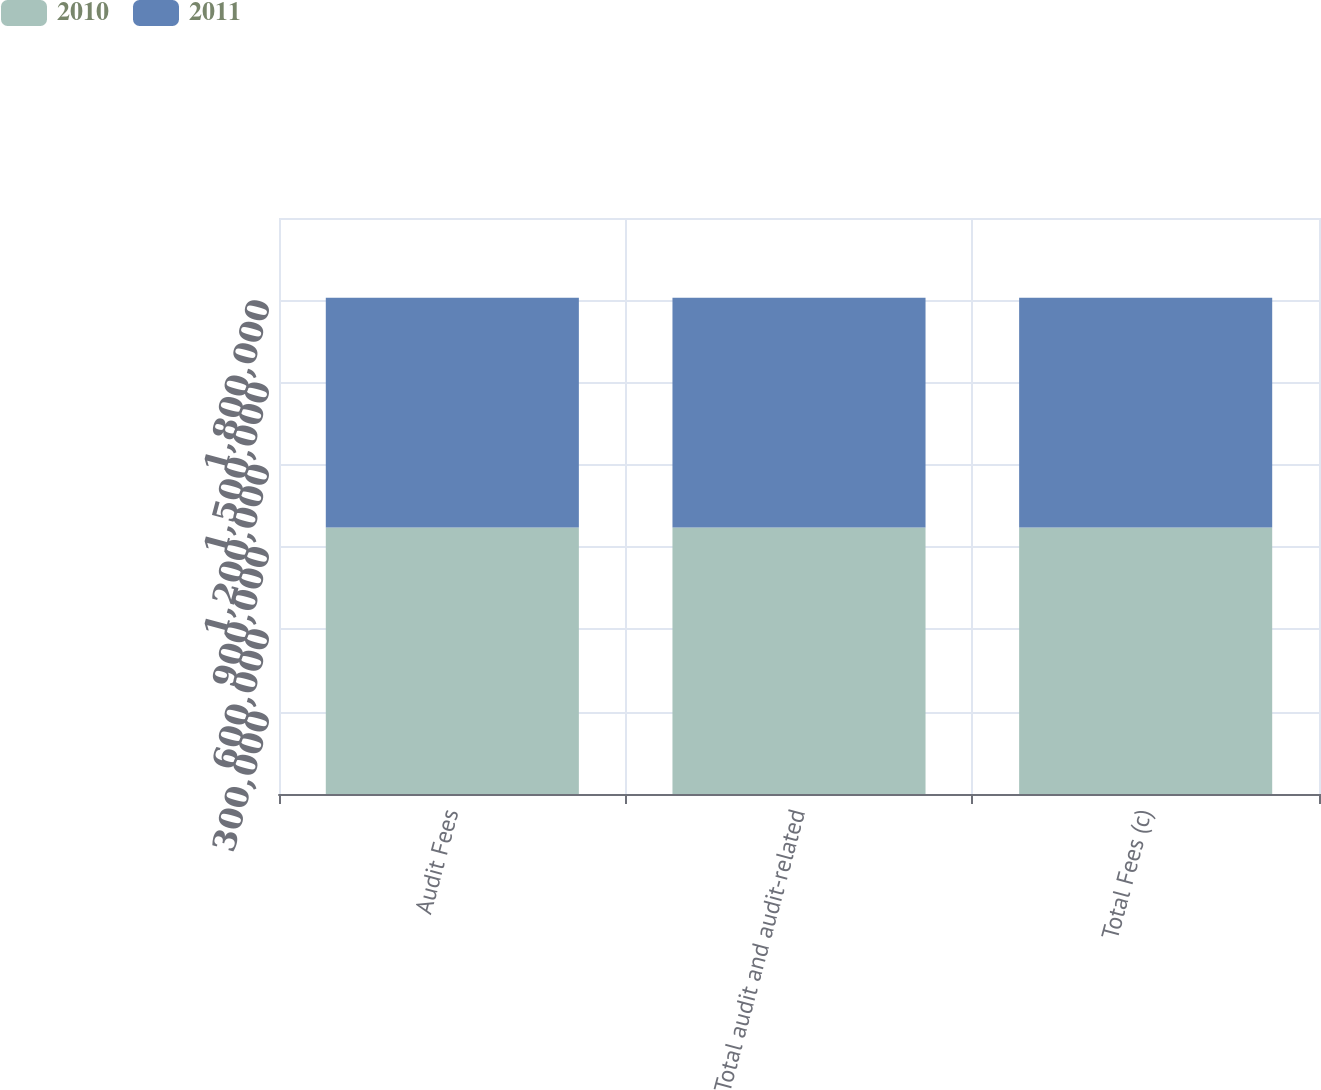Convert chart to OTSL. <chart><loc_0><loc_0><loc_500><loc_500><stacked_bar_chart><ecel><fcel>Audit Fees<fcel>Total audit and audit-related<fcel>Total Fees (c)<nl><fcel>2010<fcel>971218<fcel>971218<fcel>971218<nl><fcel>2011<fcel>838092<fcel>838092<fcel>838092<nl></chart> 